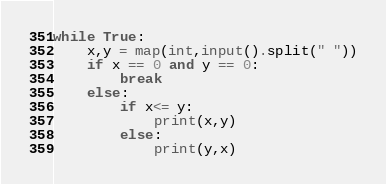Convert code to text. <code><loc_0><loc_0><loc_500><loc_500><_Python_>while True:
    x,y = map(int,input().split(" "))
    if x == 0 and y == 0:
        break
    else:
        if x<= y:
            print(x,y)
        else:
            print(y,x)
</code> 